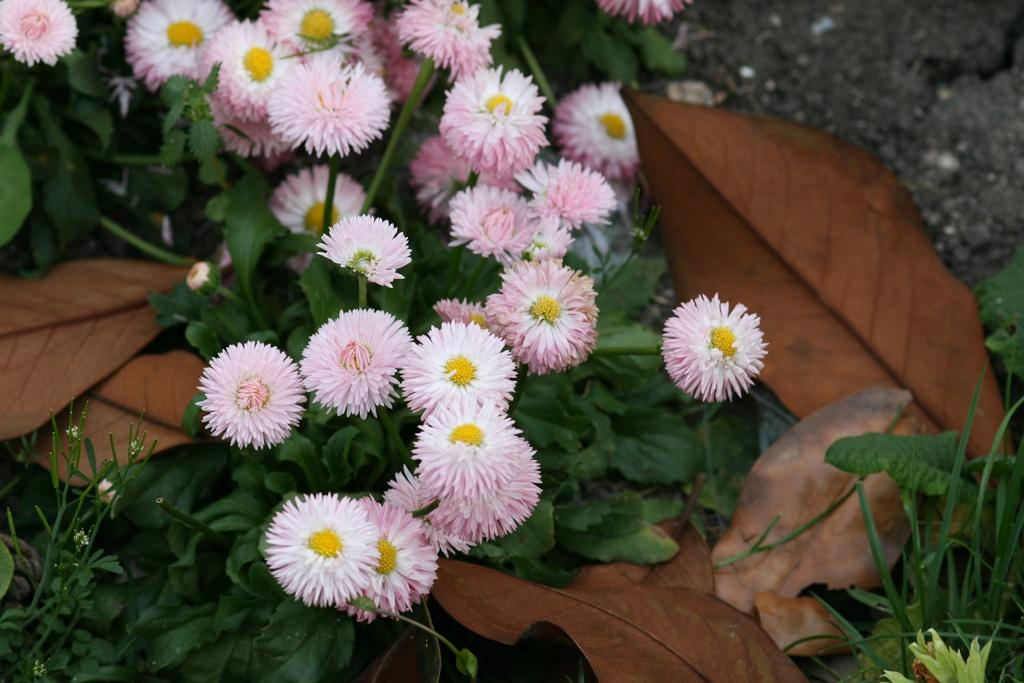What type of living organisms are present in the image? There are plants in the image. What are the main parts of the plants that can be seen? The plants have leaves, stems, and flowers. Are there any fallen leaves in the image? Yes, there are dry leaves in the image. What type of spacecraft can be seen in the image? There is no spacecraft present in the image; it features plants with leaves, stems, flowers, and dry leaves. What type of yam is being grown in the image? The image does not show any yams being grown; it features plants with leaves, stems, flowers, and dry leaves. 